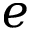Convert formula to latex. <formula><loc_0><loc_0><loc_500><loc_500>e</formula> 